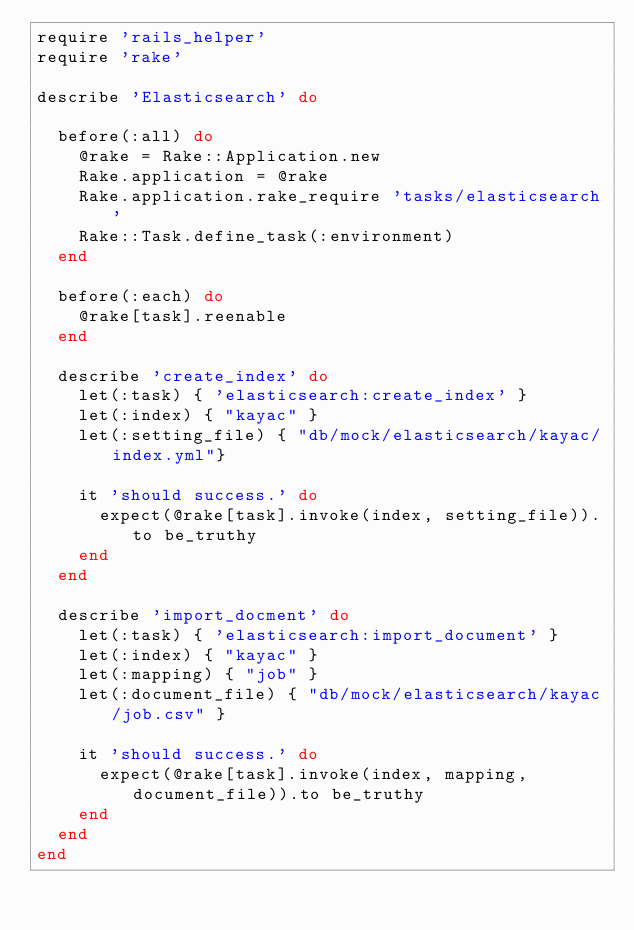Convert code to text. <code><loc_0><loc_0><loc_500><loc_500><_Ruby_>require 'rails_helper'
require 'rake'

describe 'Elasticsearch' do

  before(:all) do
    @rake = Rake::Application.new
    Rake.application = @rake
    Rake.application.rake_require 'tasks/elasticsearch'
    Rake::Task.define_task(:environment)
  end

  before(:each) do
    @rake[task].reenable
  end

  describe 'create_index' do
    let(:task) { 'elasticsearch:create_index' }
    let(:index) { "kayac" }
    let(:setting_file) { "db/mock/elasticsearch/kayac/index.yml"}

    it 'should success.' do
      expect(@rake[task].invoke(index, setting_file)).to be_truthy
    end
  end

  describe 'import_docment' do
    let(:task) { 'elasticsearch:import_document' }
    let(:index) { "kayac" }
    let(:mapping) { "job" }
    let(:document_file) { "db/mock/elasticsearch/kayac/job.csv" }

    it 'should success.' do
      expect(@rake[task].invoke(index, mapping, document_file)).to be_truthy
    end
  end
end
</code> 